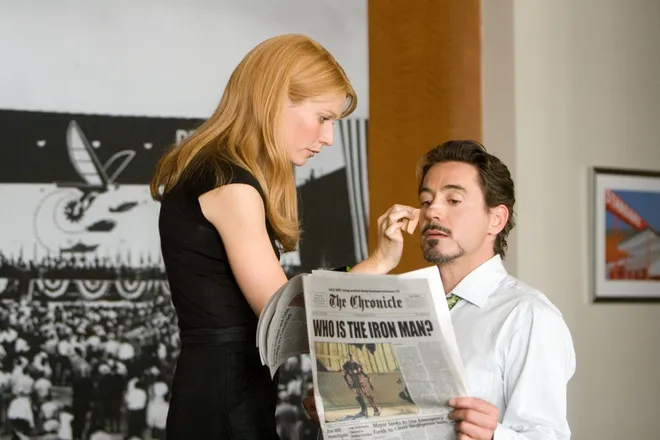Explain the visual content of the image in great detail. This image portrays a tender and pivotal moment from the movie 'Iron Man'. On the left, Gwyneth Paltrow, who plays Pepper Potts, stands dressed in an elegant, black dress. Her expression is soft and caring as she reaches out to gently touch the face of Tony Stark, played by Robert Downey Jr., who is seated on the right side. Stark looks up from the newspaper he's holding, titled 'The Chronicle', with the headline 'Who is the Iron Man?'. The setting likely represents a private room, filled with subtle hues and minimal furnishings suggestive of Stark's refined taste. This scene underscores a critical narrative development, exploring themes of identity and discovery central to the film. 